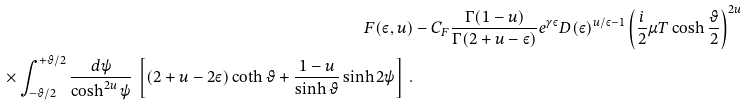Convert formula to latex. <formula><loc_0><loc_0><loc_500><loc_500>F ( \varepsilon , u ) & - C _ { F } \frac { \Gamma ( 1 - u ) } { \Gamma ( 2 + u - \varepsilon ) } e ^ { \gamma \varepsilon } D ( \varepsilon ) ^ { u / \varepsilon - 1 } \left ( \frac { i } { 2 } \mu T \cosh \frac { \vartheta } { 2 } \right ) ^ { 2 u } \\ \times \int _ { - \vartheta / 2 } ^ { + \vartheta / 2 } \frac { d \psi } { \cosh ^ { 2 u } \psi } \, \left [ ( 2 + u - 2 \varepsilon ) \coth \vartheta + \frac { 1 - u } { \sinh \vartheta } \sinh 2 \psi \right ] \, .</formula> 